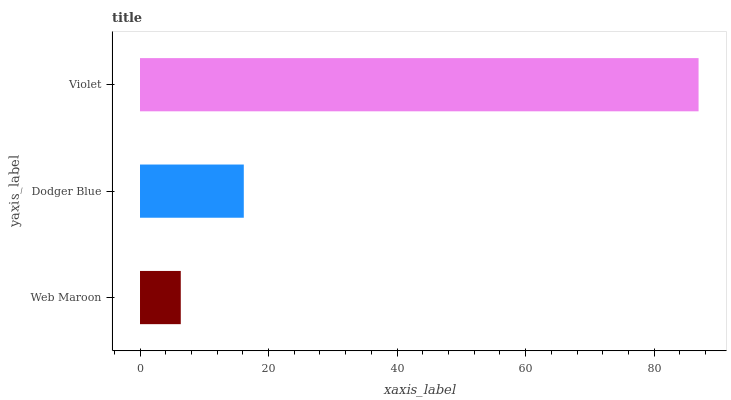Is Web Maroon the minimum?
Answer yes or no. Yes. Is Violet the maximum?
Answer yes or no. Yes. Is Dodger Blue the minimum?
Answer yes or no. No. Is Dodger Blue the maximum?
Answer yes or no. No. Is Dodger Blue greater than Web Maroon?
Answer yes or no. Yes. Is Web Maroon less than Dodger Blue?
Answer yes or no. Yes. Is Web Maroon greater than Dodger Blue?
Answer yes or no. No. Is Dodger Blue less than Web Maroon?
Answer yes or no. No. Is Dodger Blue the high median?
Answer yes or no. Yes. Is Dodger Blue the low median?
Answer yes or no. Yes. Is Violet the high median?
Answer yes or no. No. Is Web Maroon the low median?
Answer yes or no. No. 